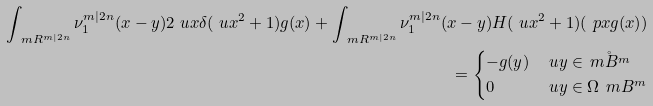<formula> <loc_0><loc_0><loc_500><loc_500>\int _ { \ m R ^ { m | 2 n } } \nu _ { 1 } ^ { m | 2 n } ( x - y ) 2 \ u x \delta ( \ u x ^ { 2 } + 1 ) g ( x ) + \int _ { \ m R ^ { m | 2 n } } \nu _ { 1 } ^ { m | 2 n } ( x - y ) H ( \ u x ^ { 2 } + 1 ) ( \ p x g ( x ) ) \\ = \begin{cases} - g ( y ) & \ u y \in \mathring { \ m B ^ { m } } \\ 0 & \ u y \in \Omega \ \ m B ^ { m } \end{cases}</formula> 